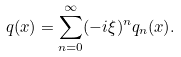<formula> <loc_0><loc_0><loc_500><loc_500>q ( x ) = \sum ^ { \infty } _ { n = 0 } ( - i \xi ) ^ { n } q _ { n } ( x ) .</formula> 